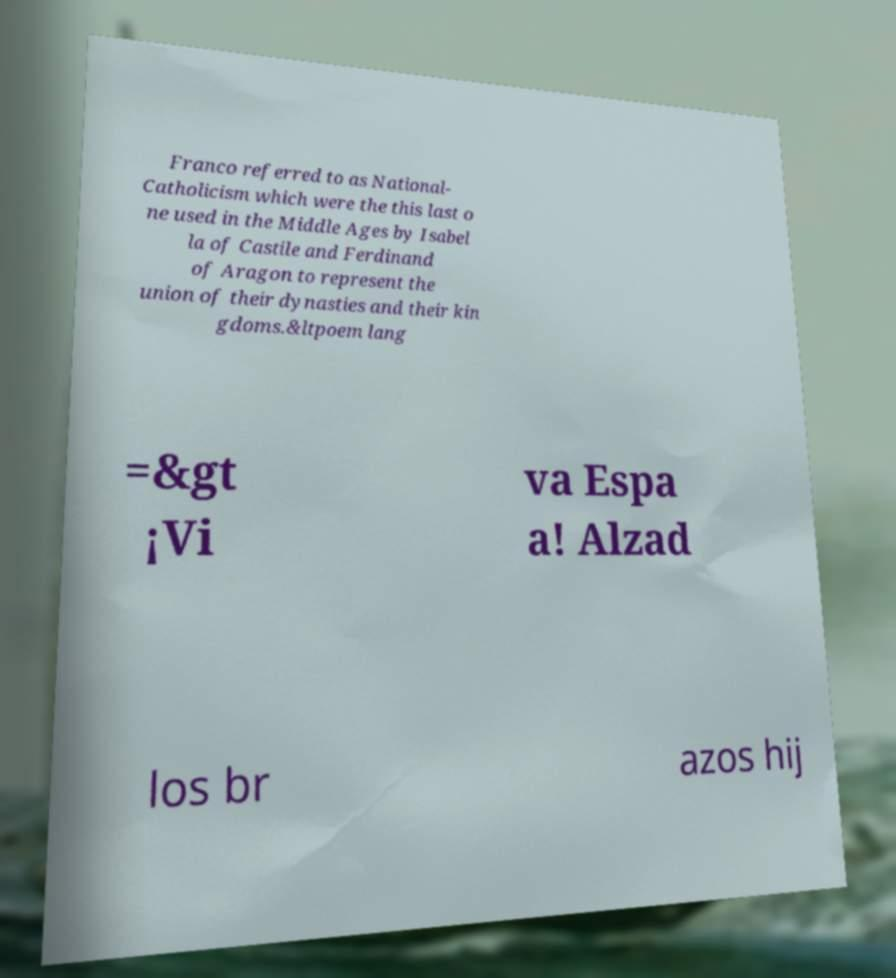There's text embedded in this image that I need extracted. Can you transcribe it verbatim? Franco referred to as National- Catholicism which were the this last o ne used in the Middle Ages by Isabel la of Castile and Ferdinand of Aragon to represent the union of their dynasties and their kin gdoms.&ltpoem lang =&gt ¡Vi va Espa a! Alzad los br azos hij 